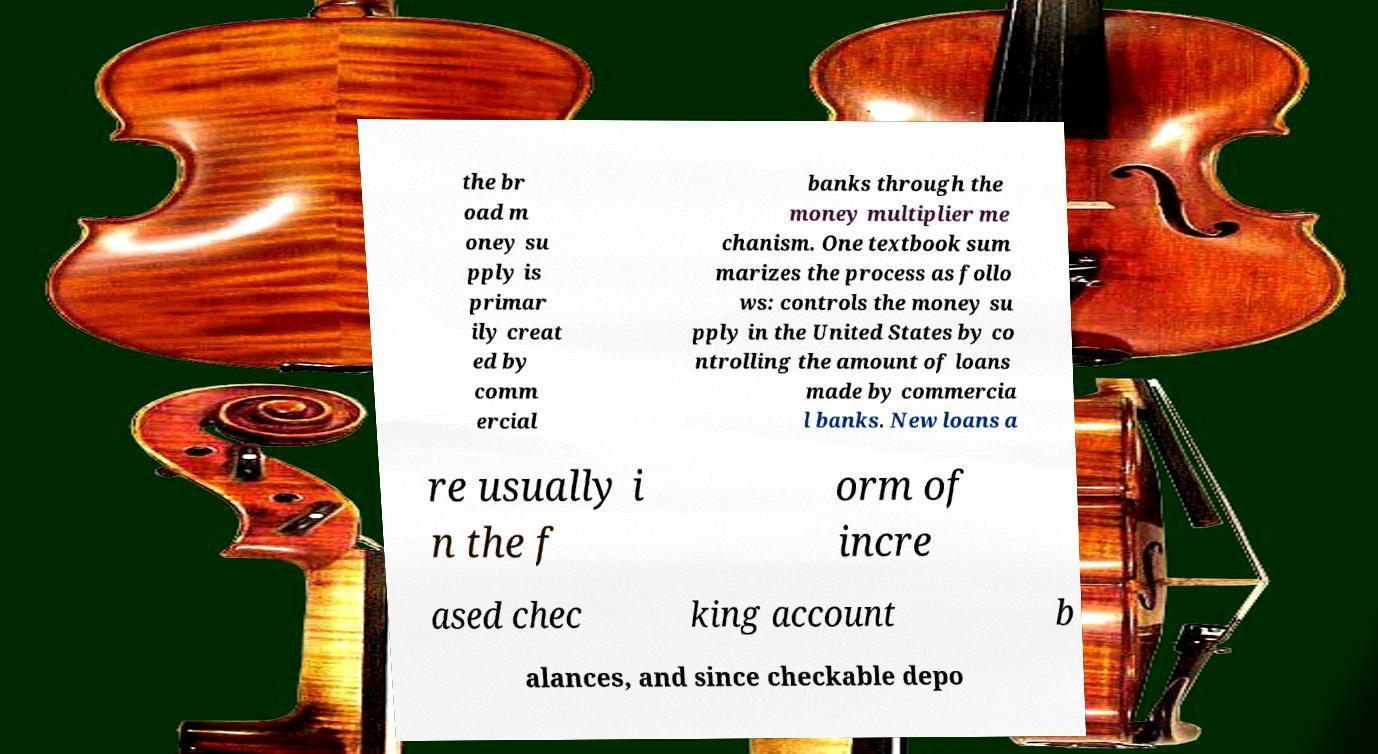Could you assist in decoding the text presented in this image and type it out clearly? the br oad m oney su pply is primar ily creat ed by comm ercial banks through the money multiplier me chanism. One textbook sum marizes the process as follo ws: controls the money su pply in the United States by co ntrolling the amount of loans made by commercia l banks. New loans a re usually i n the f orm of incre ased chec king account b alances, and since checkable depo 